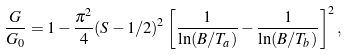Convert formula to latex. <formula><loc_0><loc_0><loc_500><loc_500>\frac { G } { G _ { 0 } } = 1 - \frac { \pi ^ { 2 } } { 4 } ( S - 1 / 2 ) ^ { 2 } \left [ \frac { 1 } { \ln ( B / T _ { a } ) } - \frac { 1 } { \ln ( B / T _ { b } ) } \right ] ^ { 2 } ,</formula> 